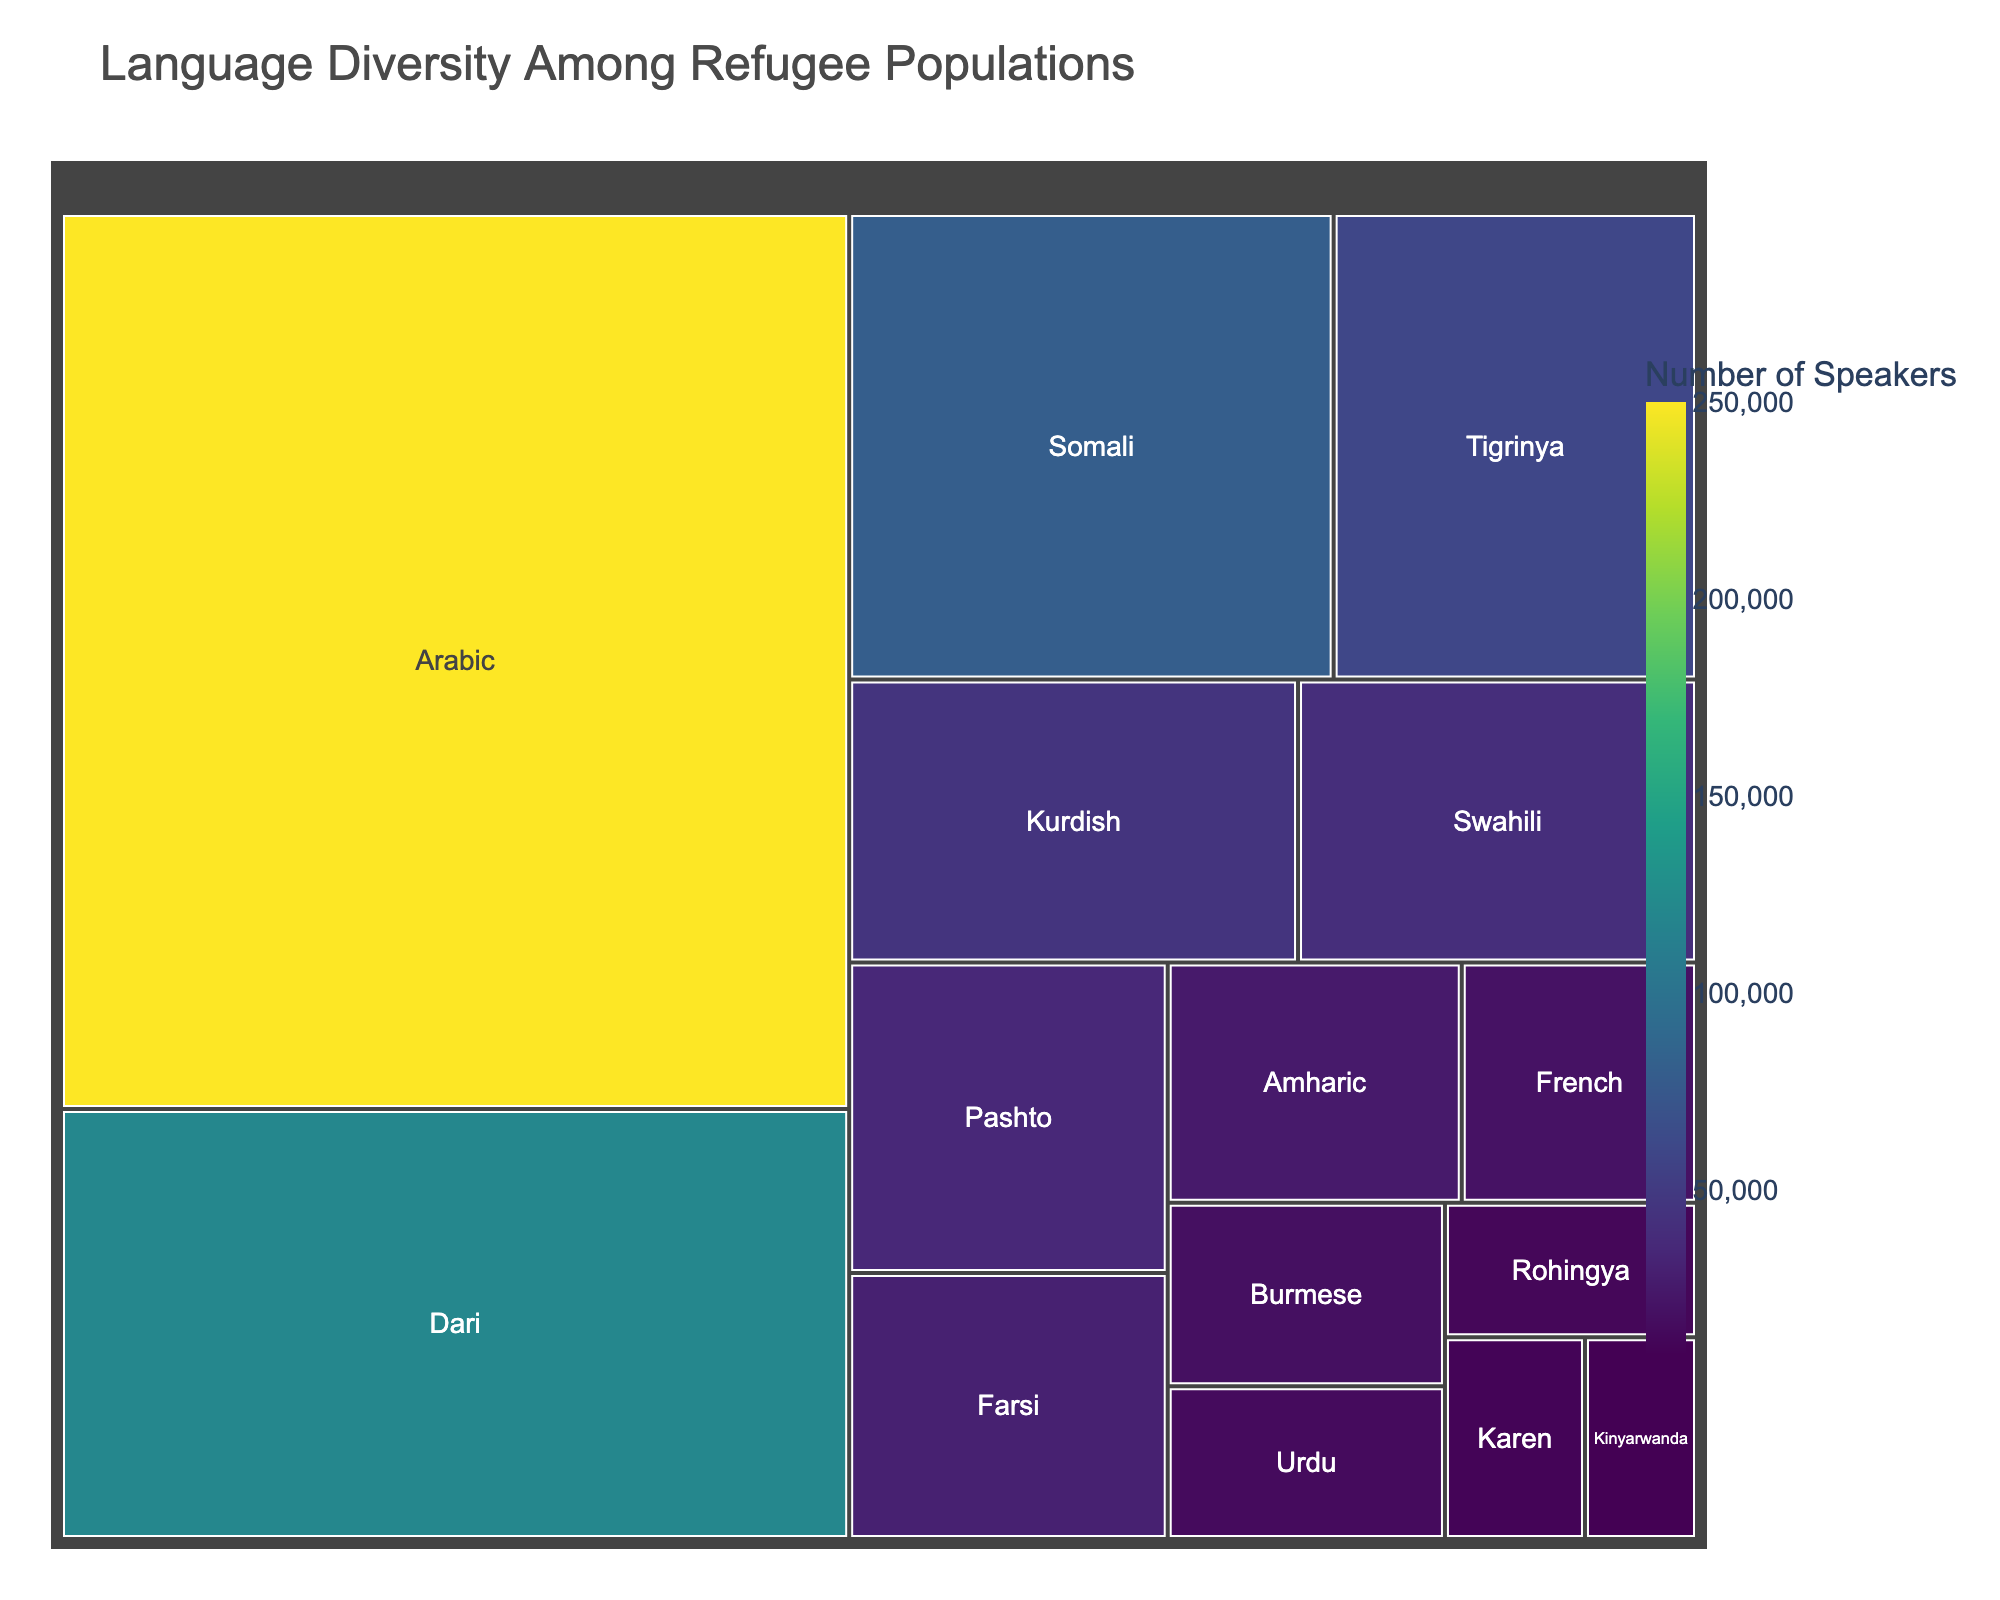Which language has the most speakers among the refugee populations? By visually inspecting the treemap, we can see that the largest block represents the language with the highest number of speakers.
Answer: Arabic How many speakers does Dari have? Refer to the corresponding block for Dari in the treemap, where the number of speakers is displayed.
Answer: 120,000 Is Kurdish spoken more widely than Pashto among refugee populations? Compare the block sizes and the labeled speaker counts of Kurdish and Pashto. Kurdish has 45,000 speakers, and Pashto has 35,000.
Answer: Yes Which languages have fewer than 20,000 speakers? By examining the smaller blocks and their labeled speaker counts in the treemap, we find French (20,000), Burmese (18,000), Urdu (15,000), Rohingya (12,000), Karen (10,000), and Kinyarwanda (8,000).
Answer: French, Burmese, Urdu, Rohingya, Karen, Kinyarwanda What is the combined number of speakers for Somali and Tigrinya? Find the number of speakers for both languages, then sum them up: Somali has 80,000 and Tigrinya has 60,000, so the total is 80,000 + 60,000 = 140,000.
Answer: 140,000 Which language within the shown treemap has the least number of speakers? By locating the smallest block and checking its label, Kinyarwanda has the least number of speakers.
Answer: Kinyarwanda How many more speakers does Swahili have compared to Urdu? Subtract the number of Urdu speakers from the number of Swahili speakers: 40,000 - 15,000 = 25,000.
Answer: 25,000 Among Amharic, French, and Burmese, which language has the highest number of speakers? Compare the number of speakers labeled on the blocks for Amharic (25,000), French (20,000), and Burmese (18,000). Amharic has the highest number.
Answer: Amharic What is the total number of speakers for all languages listed? Sum the number of speakers for each language: 250,000 (Arabic) + 120,000 (Dari) + 80,000 (Somali) + 60,000 (Tigrinya) + 45,000 (Kurdish) + 40,000 (Swahili) + 35,000 (Pashto) + 30,000 (Farsi) + 25,000 (Amharic) + 20,000 (French) + 18,000 (Burmese) + 15,000 (Urdu) + 12,000 (Rohingya) + 10,000 (Karen) + 8,000 (Kinyarwanda). This totals to 788,000 speakers.
Answer: 788,000 Between Farsi and Pashto, which language has fewer speakers and by how much? Compare the speaker counts for both languages: Farsi has 30,000 and Pashto has 35,000. Farsi has 5,000 fewer speakers.
Answer: Farsi by 5,000 